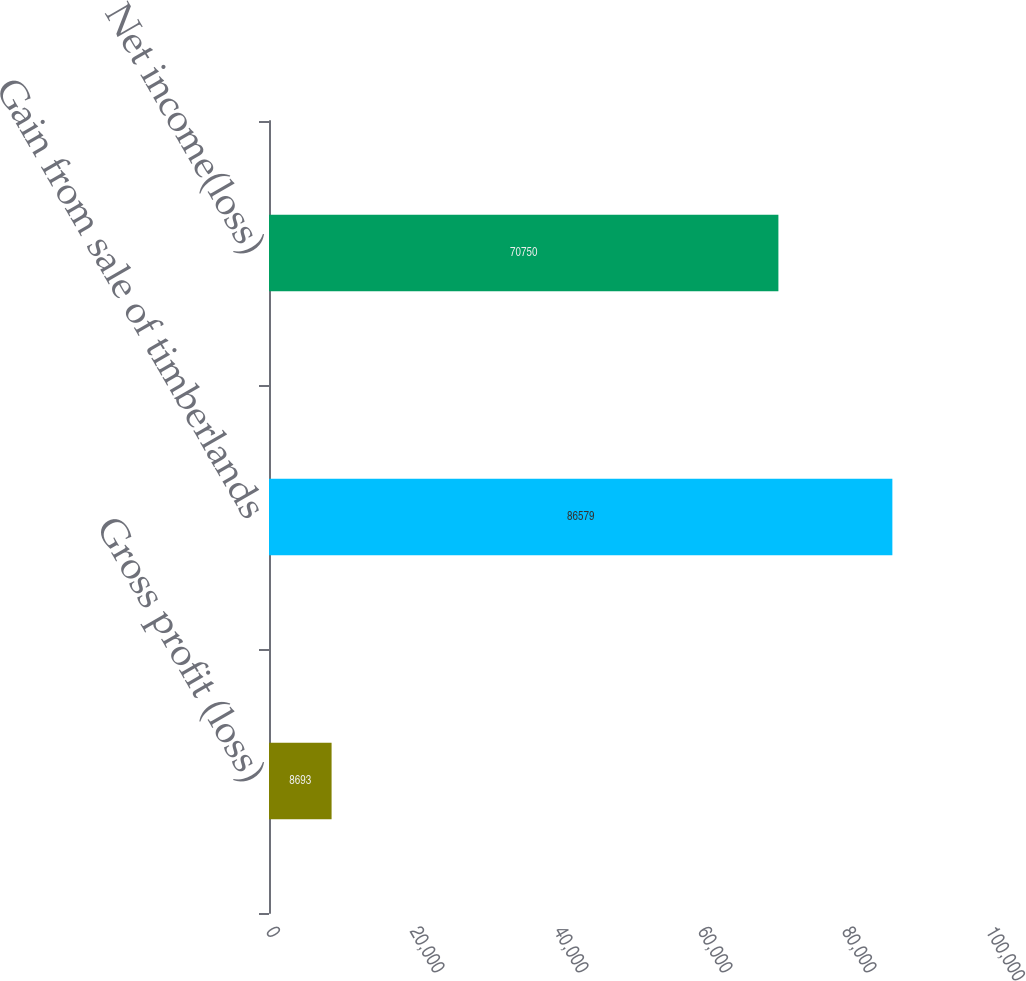Convert chart to OTSL. <chart><loc_0><loc_0><loc_500><loc_500><bar_chart><fcel>Gross profit (loss)<fcel>Gain from sale of timberlands<fcel>Net income(loss)<nl><fcel>8693<fcel>86579<fcel>70750<nl></chart> 